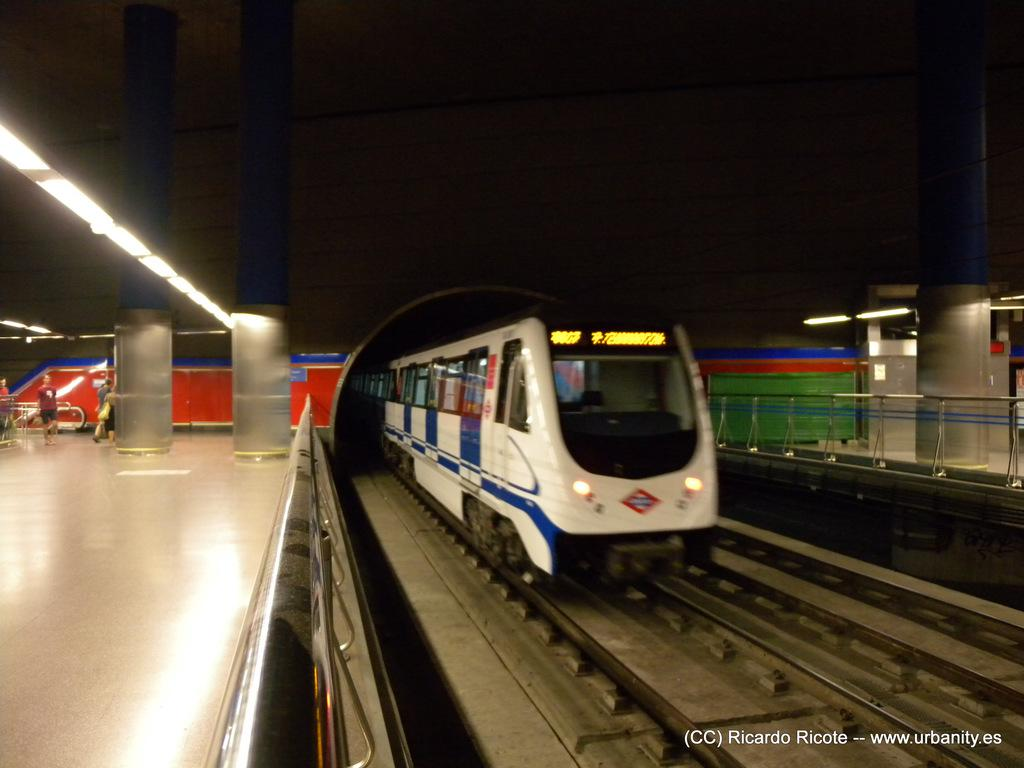What is the main subject of the image? The main subject of the image is a train on a railway track. What can be seen alongside the railway track? There are fences and pillars in the image. What type of lighting is present in the image? There are lights in the image. Where are the people located in the image? The people are on a platform in the image. What else is visible in the image besides the train and people? There are objects in the image. How would you describe the overall appearance of the image? The background of the image is dark. What type of plate is being used for the treatment in the image? There is no plate or treatment present in the image. How many yards of fabric are visible in the image? There is no fabric or yard measurement in the image. 